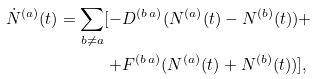Convert formula to latex. <formula><loc_0><loc_0><loc_500><loc_500>\dot { N } ^ { ( a ) } ( t ) = \sum _ { b \neq a } [ - & D ^ { ( b \, a ) } ( N ^ { ( a ) } ( t ) - N ^ { ( b ) } ( t ) ) + \\ + & F ^ { ( b \, a ) } ( N ^ { ( a ) } ( t ) + N ^ { ( b ) } ( t ) ) ] ,</formula> 